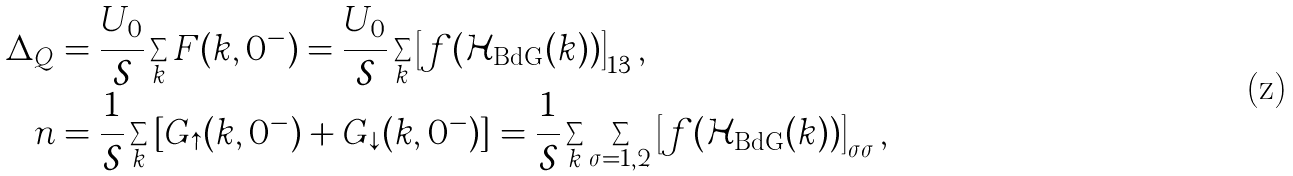<formula> <loc_0><loc_0><loc_500><loc_500>\Delta _ { Q } & = \frac { U _ { 0 } } { \mathcal { S } } \sum _ { k } F ( { k } , 0 ^ { - } ) = \frac { U _ { 0 } } { \mathcal { S } } \sum _ { k } \left [ f ( \mathcal { H } _ { \text {BdG} } ( { k } ) ) \right ] _ { 1 3 } , \\ n & = \frac { 1 } { \mathcal { S } } \sum _ { k } \left [ G _ { \uparrow } ( { k } , 0 ^ { - } ) + G _ { \downarrow } ( { k } , 0 ^ { - } ) \right ] = \frac { 1 } { \mathcal { S } } \sum _ { k } \sum _ { \sigma = 1 , 2 } \left [ f ( \mathcal { H } _ { \text {BdG} } ( { k } ) ) \right ] _ { \sigma \sigma } ,</formula> 